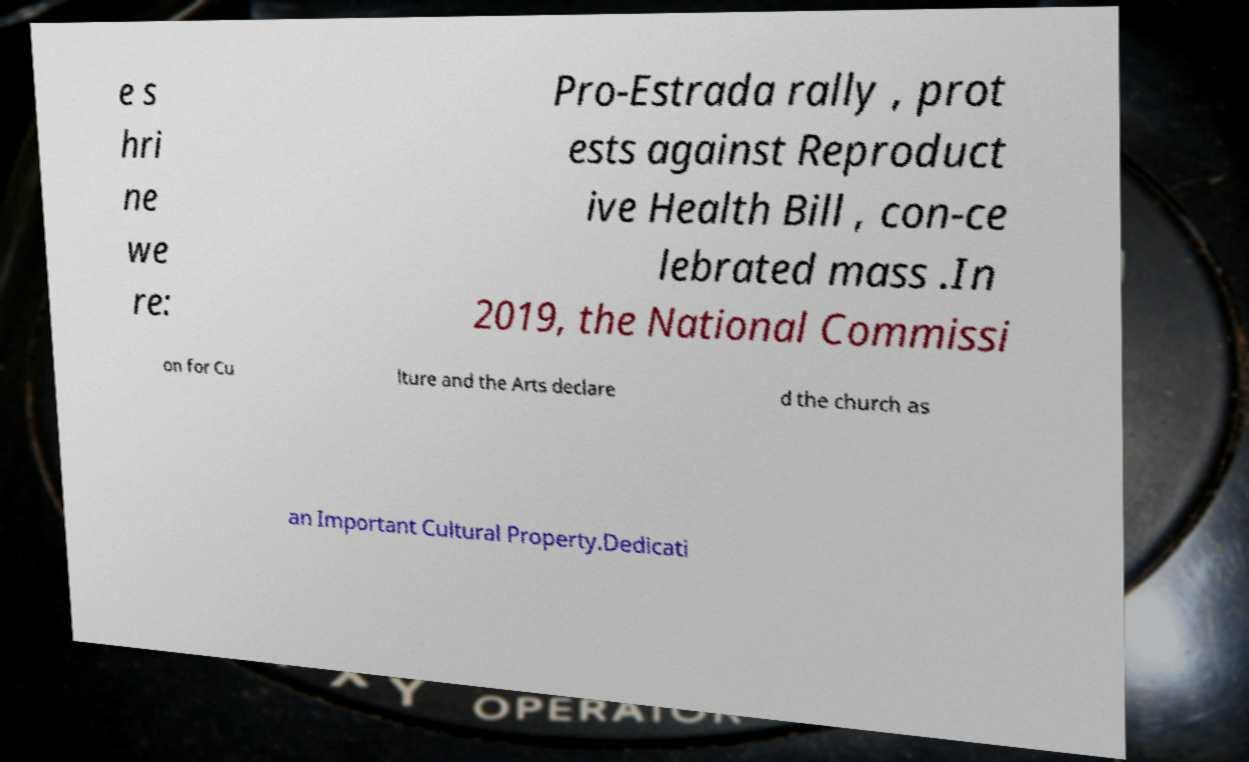For documentation purposes, I need the text within this image transcribed. Could you provide that? e s hri ne we re: Pro-Estrada rally , prot ests against Reproduct ive Health Bill , con-ce lebrated mass .In 2019, the National Commissi on for Cu lture and the Arts declare d the church as an Important Cultural Property.Dedicati 